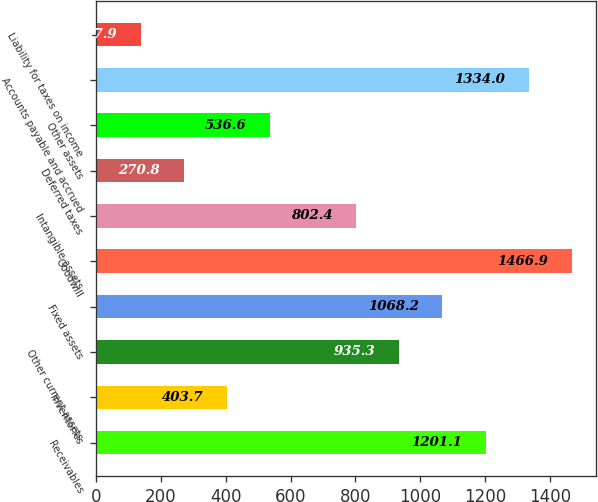Convert chart to OTSL. <chart><loc_0><loc_0><loc_500><loc_500><bar_chart><fcel>Receivables<fcel>Inventories<fcel>Other current assets<fcel>Fixed assets<fcel>Goodwill<fcel>Intangible assets<fcel>Deferred taxes<fcel>Other assets<fcel>Accounts payable and accrued<fcel>Liability for taxes on income<nl><fcel>1201.1<fcel>403.7<fcel>935.3<fcel>1068.2<fcel>1466.9<fcel>802.4<fcel>270.8<fcel>536.6<fcel>1334<fcel>137.9<nl></chart> 